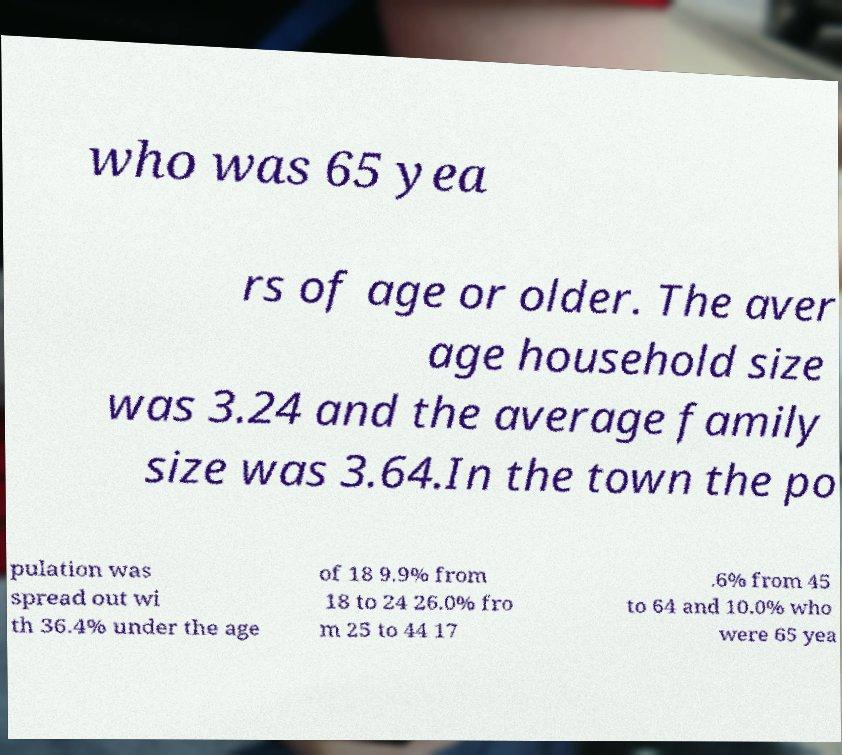There's text embedded in this image that I need extracted. Can you transcribe it verbatim? who was 65 yea rs of age or older. The aver age household size was 3.24 and the average family size was 3.64.In the town the po pulation was spread out wi th 36.4% under the age of 18 9.9% from 18 to 24 26.0% fro m 25 to 44 17 .6% from 45 to 64 and 10.0% who were 65 yea 